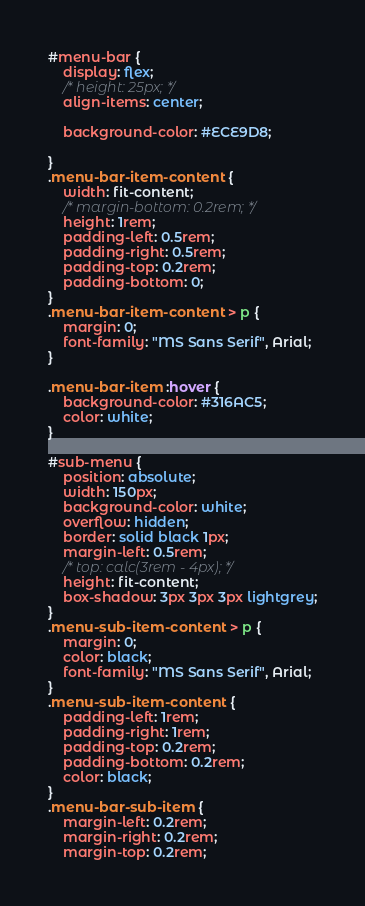Convert code to text. <code><loc_0><loc_0><loc_500><loc_500><_CSS_>#menu-bar {
    display: flex;
    /* height: 25px; */
    align-items: center;

    background-color: #ECE9D8;

}
.menu-bar-item-content {
    width: fit-content;
    /* margin-bottom: 0.2rem; */
    height: 1rem;
    padding-left: 0.5rem;
    padding-right: 0.5rem;
    padding-top: 0.2rem;
    padding-bottom: 0;
}
.menu-bar-item-content > p {
    margin: 0;
    font-family: "MS Sans Serif", Arial;
}

.menu-bar-item :hover {
    background-color: #316AC5;
    color: white;
}

#sub-menu {
    position: absolute;
    width: 150px;
    background-color: white;
    overflow: hidden;
    border: solid black 1px;
    margin-left: 0.5rem;
    /* top: calc(3rem - 4px); */
    height: fit-content;
    box-shadow: 3px 3px 3px lightgrey;
}
.menu-sub-item-content > p {
    margin: 0;
    color: black;
    font-family: "MS Sans Serif", Arial;
}
.menu-sub-item-content {
    padding-left: 1rem;
    padding-right: 1rem;
    padding-top: 0.2rem;
    padding-bottom: 0.2rem;
    color: black;
}
.menu-bar-sub-item {
    margin-left: 0.2rem;
    margin-right: 0.2rem;
    margin-top: 0.2rem;</code> 